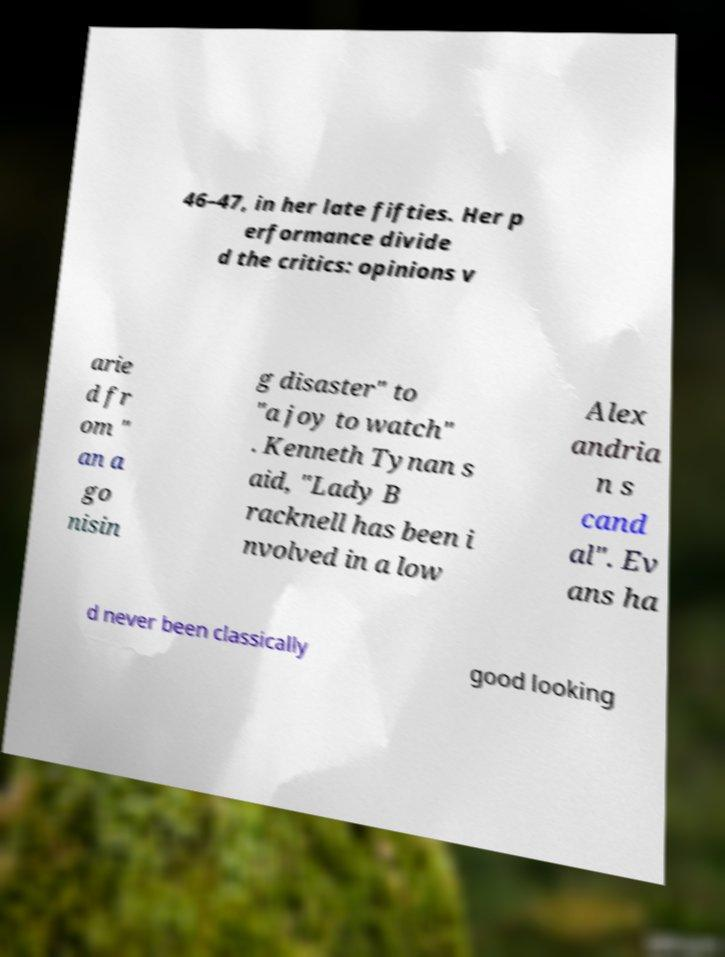There's text embedded in this image that I need extracted. Can you transcribe it verbatim? 46–47, in her late fifties. Her p erformance divide d the critics: opinions v arie d fr om " an a go nisin g disaster" to "a joy to watch" . Kenneth Tynan s aid, "Lady B racknell has been i nvolved in a low Alex andria n s cand al". Ev ans ha d never been classically good looking 